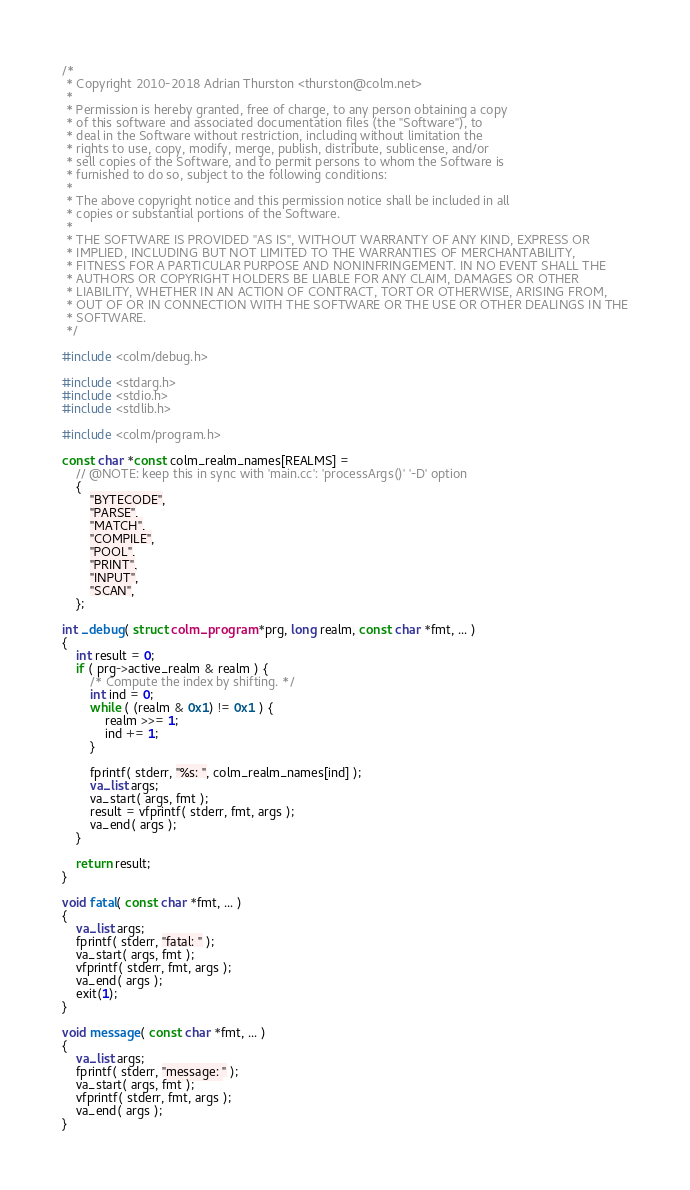<code> <loc_0><loc_0><loc_500><loc_500><_C_>/*
 * Copyright 2010-2018 Adrian Thurston <thurston@colm.net>
 *
 * Permission is hereby granted, free of charge, to any person obtaining a copy
 * of this software and associated documentation files (the "Software"), to
 * deal in the Software without restriction, including without limitation the
 * rights to use, copy, modify, merge, publish, distribute, sublicense, and/or
 * sell copies of the Software, and to permit persons to whom the Software is
 * furnished to do so, subject to the following conditions:
 *
 * The above copyright notice and this permission notice shall be included in all
 * copies or substantial portions of the Software.
 *
 * THE SOFTWARE IS PROVIDED "AS IS", WITHOUT WARRANTY OF ANY KIND, EXPRESS OR
 * IMPLIED, INCLUDING BUT NOT LIMITED TO THE WARRANTIES OF MERCHANTABILITY,
 * FITNESS FOR A PARTICULAR PURPOSE AND NONINFRINGEMENT. IN NO EVENT SHALL THE
 * AUTHORS OR COPYRIGHT HOLDERS BE LIABLE FOR ANY CLAIM, DAMAGES OR OTHER
 * LIABILITY, WHETHER IN AN ACTION OF CONTRACT, TORT OR OTHERWISE, ARISING FROM,
 * OUT OF OR IN CONNECTION WITH THE SOFTWARE OR THE USE OR OTHER DEALINGS IN THE
 * SOFTWARE.
 */

#include <colm/debug.h>

#include <stdarg.h>
#include <stdio.h>
#include <stdlib.h>

#include <colm/program.h>

const char *const colm_realm_names[REALMS] =
	// @NOTE: keep this in sync with 'main.cc': 'processArgs()' '-D' option
	{
		"BYTECODE",
		"PARSE",
		"MATCH",
		"COMPILE",
		"POOL",
		"PRINT",
		"INPUT",
		"SCAN",
	};

int _debug( struct colm_program *prg, long realm, const char *fmt, ... )
{
	int result = 0;
	if ( prg->active_realm & realm ) {
		/* Compute the index by shifting. */
		int ind = 0;
		while ( (realm & 0x1) != 0x1 ) {
			realm >>= 1;
			ind += 1;
		}

		fprintf( stderr, "%s: ", colm_realm_names[ind] );
		va_list args;
		va_start( args, fmt );
		result = vfprintf( stderr, fmt, args );
		va_end( args );
	}

	return result;
}

void fatal( const char *fmt, ... )
{
	va_list args;
	fprintf( stderr, "fatal: " );
	va_start( args, fmt );
	vfprintf( stderr, fmt, args );
	va_end( args );
	exit(1);
}

void message( const char *fmt, ... )
{
	va_list args;
	fprintf( stderr, "message: " );
	va_start( args, fmt );
	vfprintf( stderr, fmt, args );
	va_end( args );
}
</code> 